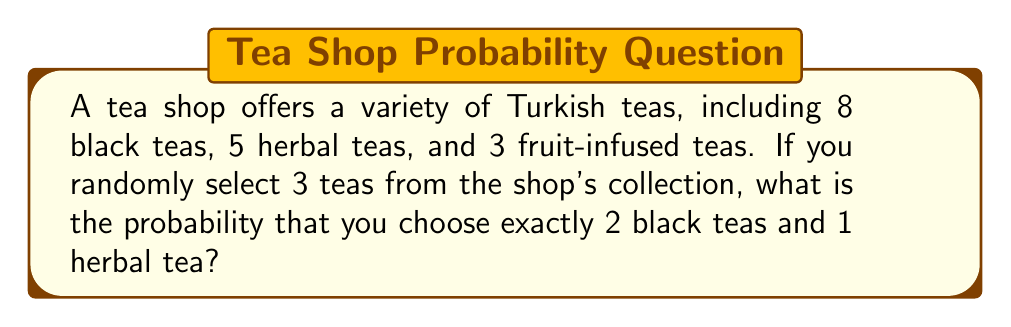Could you help me with this problem? Let's approach this step-by-step:

1) First, we need to calculate the total number of teas:
   $8 + 5 + 3 = 16$ total teas

2) Now, we need to use the combination formula to calculate:
   a) The number of ways to choose 2 black teas out of 8
   b) The number of ways to choose 1 herbal tea out of 5

3) For 2 black teas out of 8:
   $$\binom{8}{2} = \frac{8!}{2!(8-2)!} = \frac{8!}{2!6!} = 28$$

4) For 1 herbal tea out of 5:
   $$\binom{5}{1} = \frac{5!}{1!(5-1)!} = \frac{5!}{1!4!} = 5$$

5) The number of favorable outcomes is the product of these:
   $28 * 5 = 140$

6) The total number of ways to choose 3 teas out of 16 is:
   $$\binom{16}{3} = \frac{16!}{3!(16-3)!} = \frac{16!}{3!13!} = 560$$

7) The probability is then:
   $$P(\text{2 black, 1 herbal}) = \frac{\text{favorable outcomes}}{\text{total outcomes}} = \frac{140}{560} = \frac{1}{4}$$
Answer: $\frac{1}{4}$ 